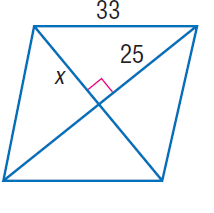Answer the mathemtical geometry problem and directly provide the correct option letter.
Question: Find x.
Choices: A: 4 \sqrt { 29 } B: 25 C: 33 D: \sqrt { 1714 } A 